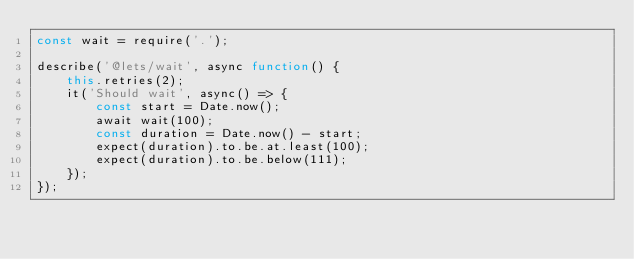<code> <loc_0><loc_0><loc_500><loc_500><_JavaScript_>const wait = require('.');

describe('@lets/wait', async function() {
	this.retries(2);
	it('Should wait', async() => {
		const start = Date.now();
		await wait(100);
		const duration = Date.now() - start;
		expect(duration).to.be.at.least(100);
		expect(duration).to.be.below(111);
	});
});
</code> 